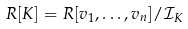<formula> <loc_0><loc_0><loc_500><loc_500>R [ K ] = R [ v _ { 1 } , \dots , v _ { n } ] / \mathcal { I } _ { K }</formula> 